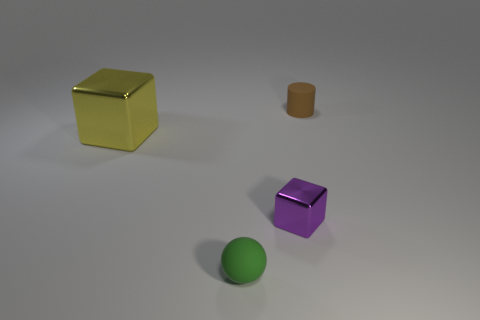Add 4 shiny balls. How many objects exist? 8 Subtract all balls. How many objects are left? 3 Subtract 0 brown blocks. How many objects are left? 4 Subtract all big shiny cubes. Subtract all big yellow objects. How many objects are left? 2 Add 4 brown objects. How many brown objects are left? 5 Add 1 purple metal cubes. How many purple metal cubes exist? 2 